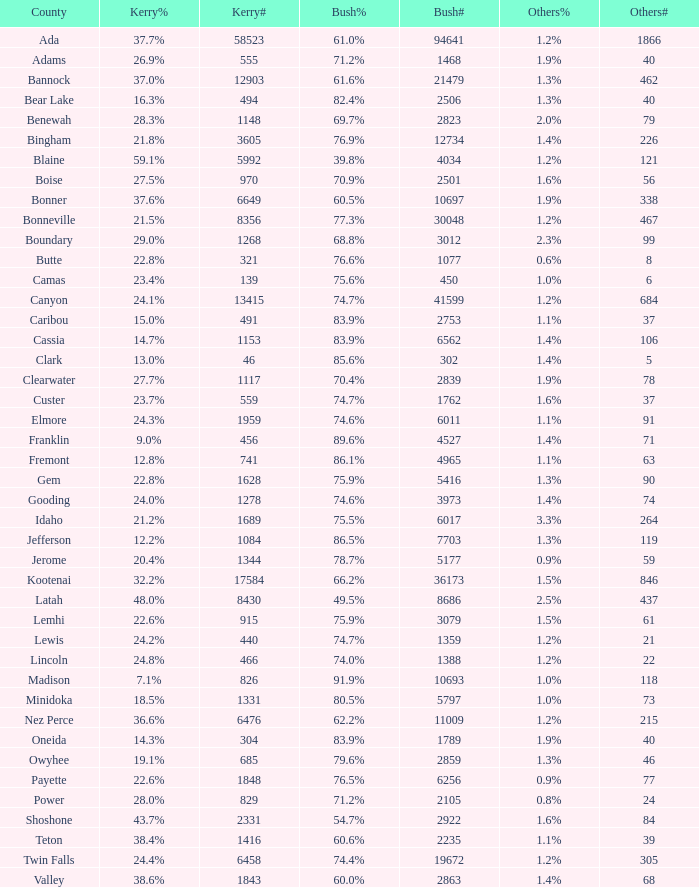How many different counts of the votes for Bush are there in the county where he got 69.7% of the votes? 1.0. 